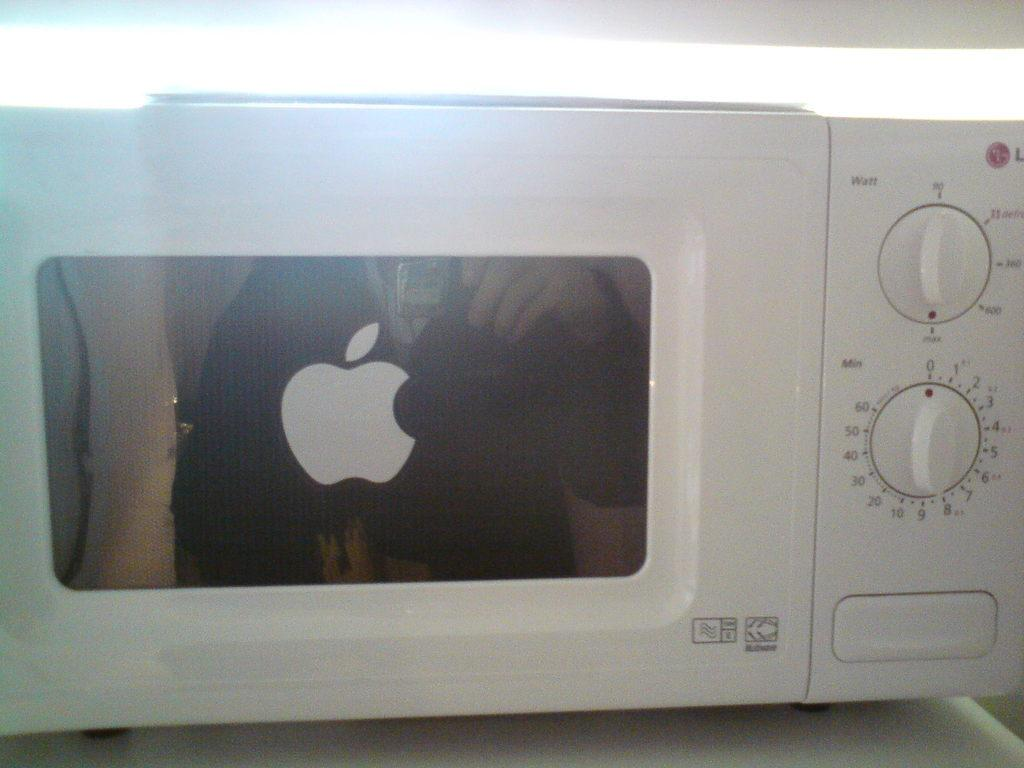<image>
Relay a brief, clear account of the picture shown. An LG Microwave with the an Apple logo stuck to the door 